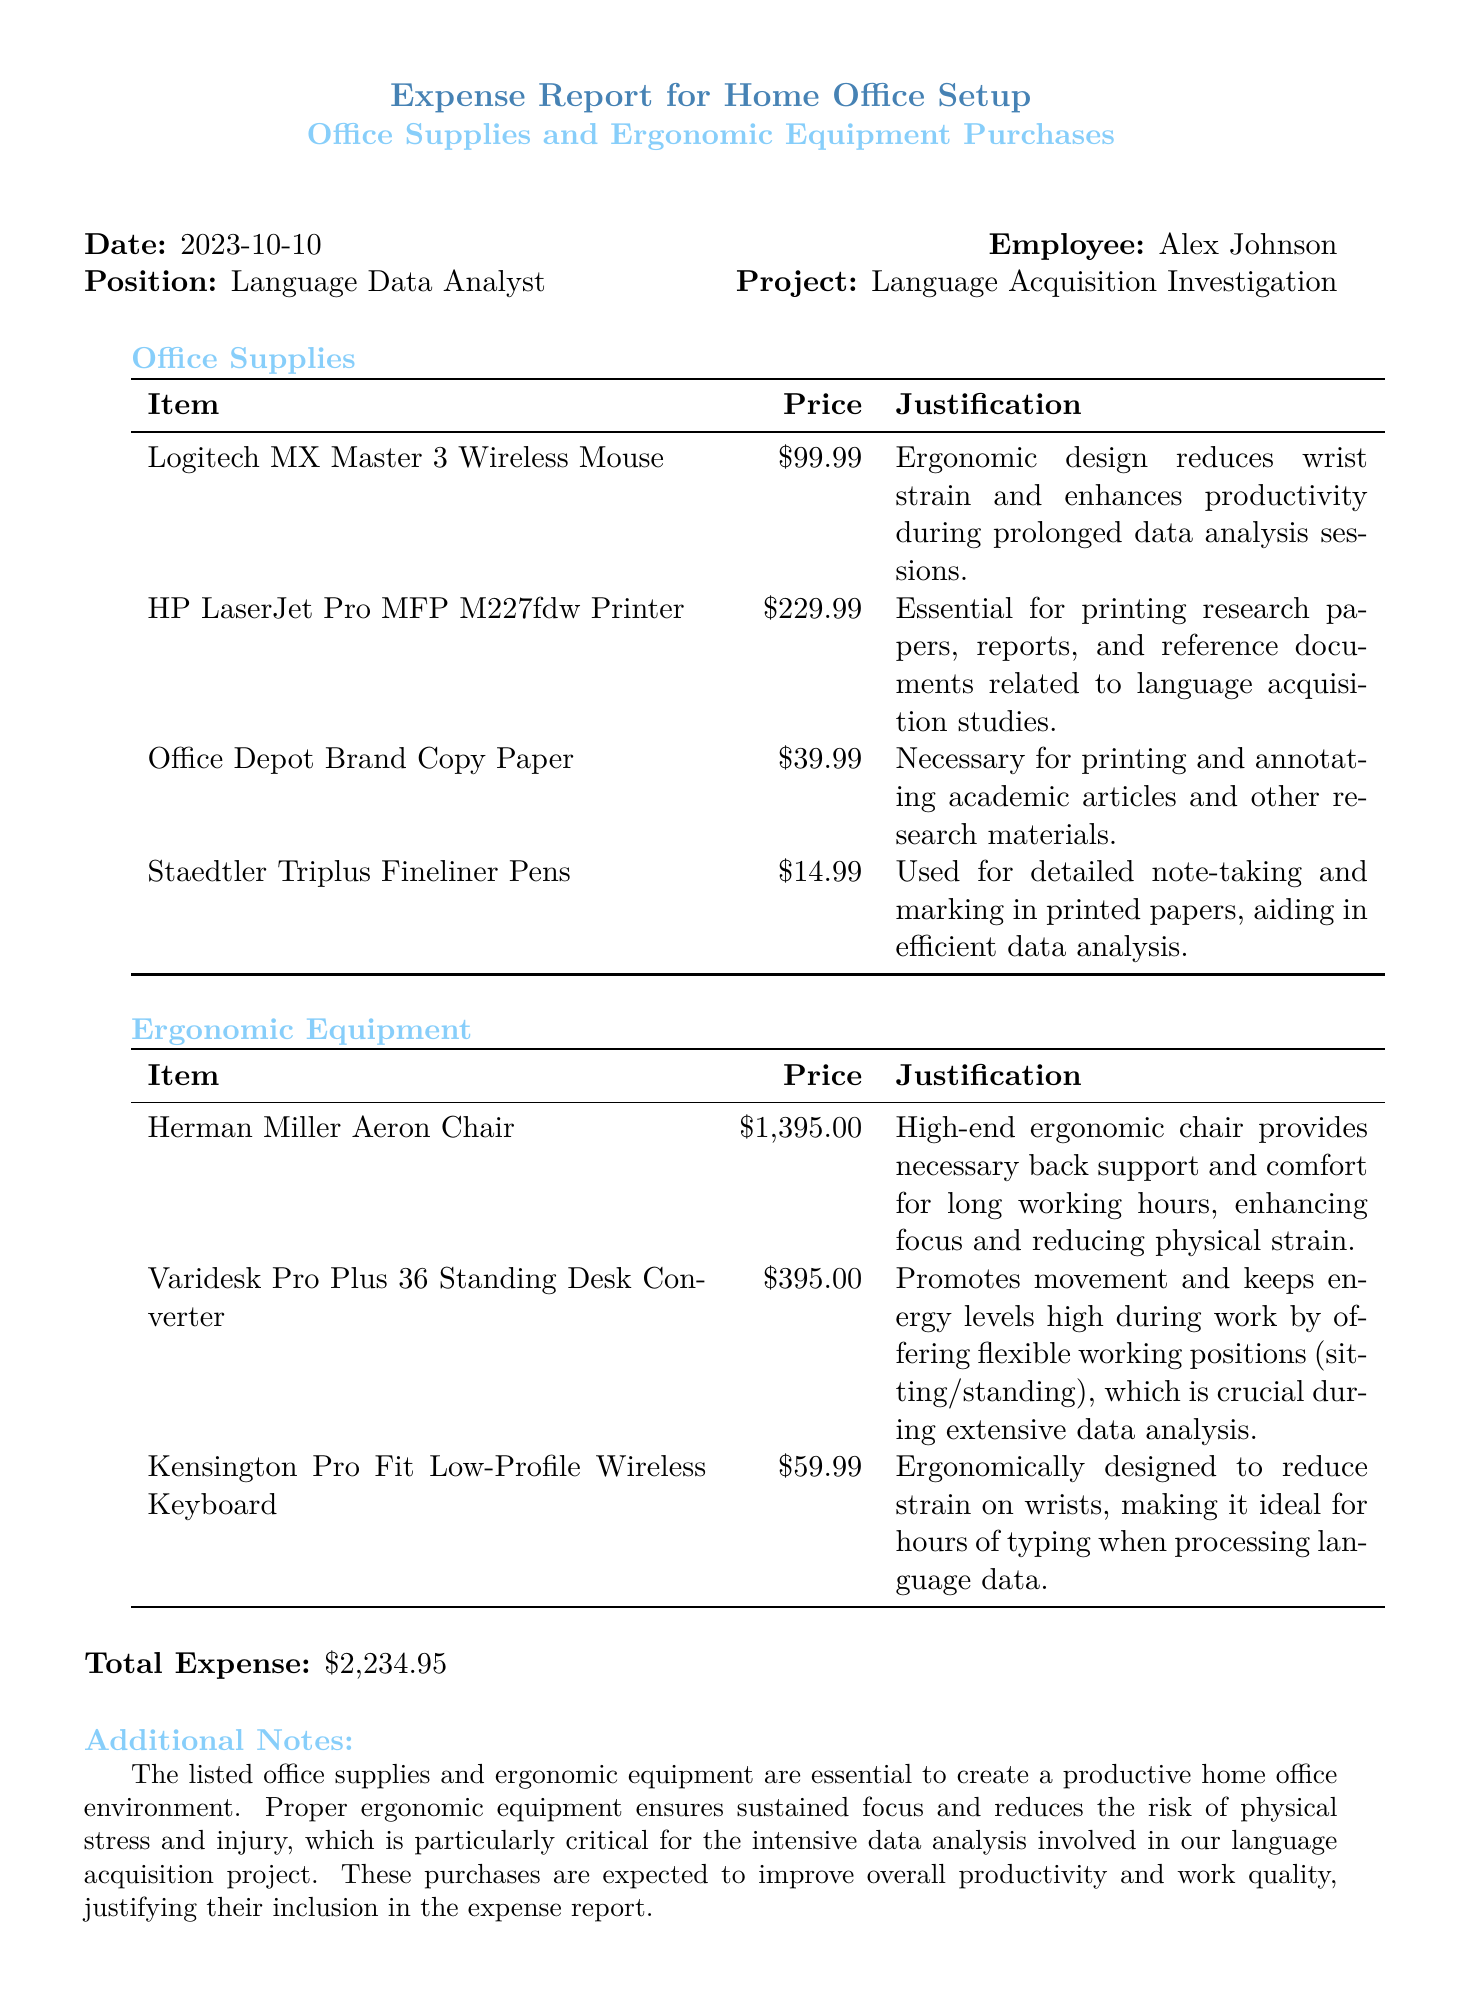What is the total expense? The total expense is clearly stated at the bottom of the report, which sums up all purchases made for office supplies and ergonomic equipment.
Answer: $2,234.95 Who is the employee submitting the report? The employee's name is given at the top of the report that identifies the individual responsible for the report.
Answer: Alex Johnson What is the price of the Herman Miller Aeron Chair? The document lists the price for each item, and for the Herman Miller Aeron Chair, it's mentioned directly in the table.
Answer: $1,395.00 What is the justification for purchasing the Logitech MX Master 3 Wireless Mouse? Each item comes with a justification, and this mouse's justification is provided in the table, explaining its benefits.
Answer: Ergonomic design reduces wrist strain and enhances productivity during prolonged data analysis sessions How many ergonomic items are listed in the report? The report includes a section for ergonomic equipment, where the number of items is directly countable from the list provided.
Answer: 3 What type of document is this? The title at the top of the document provides an indication of its classification and purpose.
Answer: Expense Report What is the price of the Varidesk Pro Plus 36 Standing Desk Converter? The price for this specific ergonomic equipment is also listed clearly in its respective table.
Answer: $395.00 What specific office supply is listed for detailed note-taking? The document specifies related office supplies, and for note-taking, it mentions a specific item in the office supplies section.
Answer: Staedtler Triplus Fineliner Pens What is the main purpose of these purchases as stated in the additional notes? The additional notes summarize the overall goal of the purchases, which relates to work efficiency and health.
Answer: Productive home office environment 